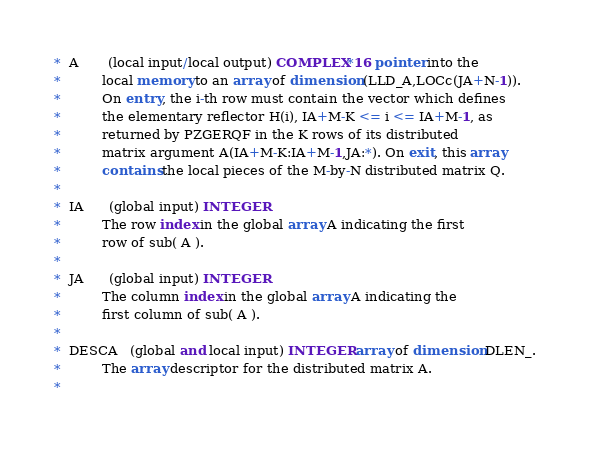<code> <loc_0><loc_0><loc_500><loc_500><_FORTRAN_>*  A       (local input/local output) COMPLEX*16 pointer into the
*          local memory to an array of dimension (LLD_A,LOCc(JA+N-1)).
*          On entry, the i-th row must contain the vector which defines
*          the elementary reflector H(i), IA+M-K <= i <= IA+M-1, as
*          returned by PZGERQF in the K rows of its distributed
*          matrix argument A(IA+M-K:IA+M-1,JA:*). On exit, this array
*          contains the local pieces of the M-by-N distributed matrix Q.
*
*  IA      (global input) INTEGER
*          The row index in the global array A indicating the first
*          row of sub( A ).
*
*  JA      (global input) INTEGER
*          The column index in the global array A indicating the
*          first column of sub( A ).
*
*  DESCA   (global and local input) INTEGER array of dimension DLEN_.
*          The array descriptor for the distributed matrix A.
*</code> 